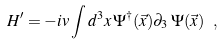<formula> <loc_0><loc_0><loc_500><loc_500>{ H } ^ { \prime } = - i v \int d ^ { 3 } x \, \Psi ^ { \dagger } ( \vec { x } ) \partial _ { 3 } \, \Psi ( \vec { x } ) \ ,</formula> 